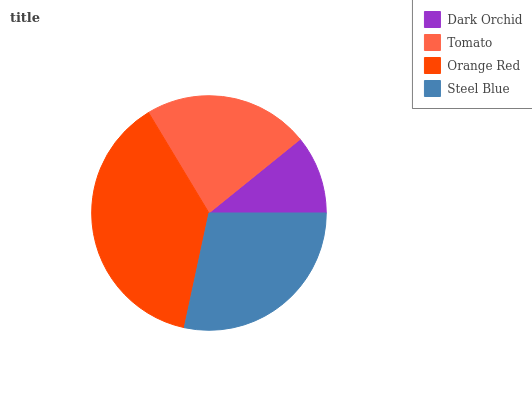Is Dark Orchid the minimum?
Answer yes or no. Yes. Is Orange Red the maximum?
Answer yes or no. Yes. Is Tomato the minimum?
Answer yes or no. No. Is Tomato the maximum?
Answer yes or no. No. Is Tomato greater than Dark Orchid?
Answer yes or no. Yes. Is Dark Orchid less than Tomato?
Answer yes or no. Yes. Is Dark Orchid greater than Tomato?
Answer yes or no. No. Is Tomato less than Dark Orchid?
Answer yes or no. No. Is Steel Blue the high median?
Answer yes or no. Yes. Is Tomato the low median?
Answer yes or no. Yes. Is Orange Red the high median?
Answer yes or no. No. Is Steel Blue the low median?
Answer yes or no. No. 